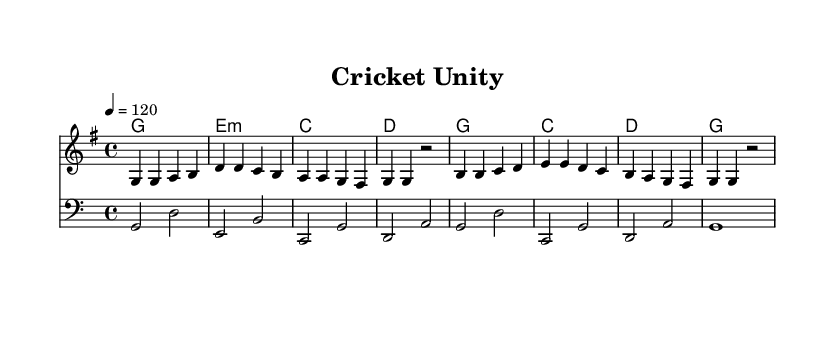What is the key signature of this music? The key signature indicates that there is one sharp, which corresponds to the G major key.
Answer: G major What is the time signature of this piece? The time signature is displayed at the beginning of the score and it shows a 4/4 time signature.
Answer: 4/4 What is the tempo marking given for this piece? The tempo marking "4 = 120" indicates that there are 120 beats per minute in each measure.
Answer: 120 How many measures are in the melody? Counting the bars in the melody part, there are a total of eight measures.
Answer: 8 Which chord is used in measure 5? By reviewing the chord changes, the chord used in measure 5 is E minor.
Answer: E minor Identify the clef used for the bass part. The bass part is notated in the bass clef, which is indicated at the beginning of the bass staff.
Answer: Bass clef What is the general theme expressed in this piece? The overall theme of the piece reflects unity and teamwork, which aligns with its title "Cricket Unity".
Answer: Unity and teamwork 